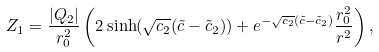Convert formula to latex. <formula><loc_0><loc_0><loc_500><loc_500>Z _ { 1 } = \frac { | Q _ { 2 } | } { r _ { 0 } ^ { 2 } } \left ( 2 \sinh ( \sqrt { c _ { 2 } } ( \tilde { c } - \tilde { c } _ { 2 } ) ) + e ^ { - \sqrt { c _ { 2 } } ( \tilde { c } - \tilde { c } _ { 2 } ) } \frac { r _ { 0 } ^ { 2 } } { r ^ { 2 } } \right ) ,</formula> 